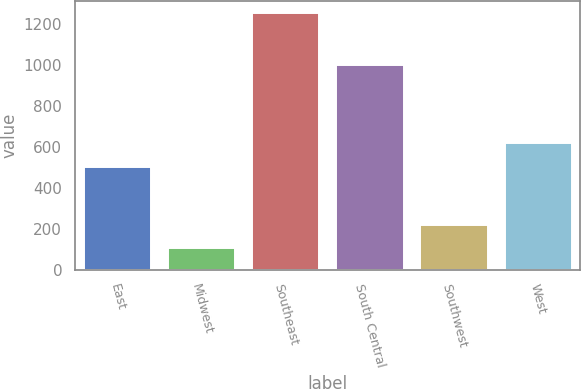Convert chart. <chart><loc_0><loc_0><loc_500><loc_500><bar_chart><fcel>East<fcel>Midwest<fcel>Southeast<fcel>South Central<fcel>Southwest<fcel>West<nl><fcel>500.3<fcel>103.6<fcel>1252.5<fcel>1000.8<fcel>218.49<fcel>616.9<nl></chart> 